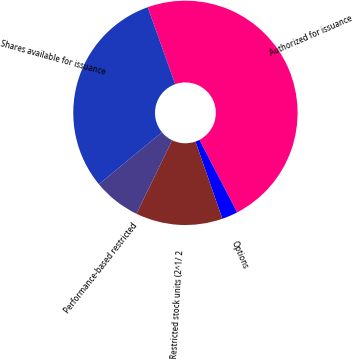Convert chart to OTSL. <chart><loc_0><loc_0><loc_500><loc_500><pie_chart><fcel>Authorized for issuance<fcel>Options<fcel>Restricted stock units (2^1/ 2<fcel>Performance-based restricted<fcel>Shares available for issuance<nl><fcel>47.84%<fcel>2.28%<fcel>12.53%<fcel>6.83%<fcel>30.52%<nl></chart> 